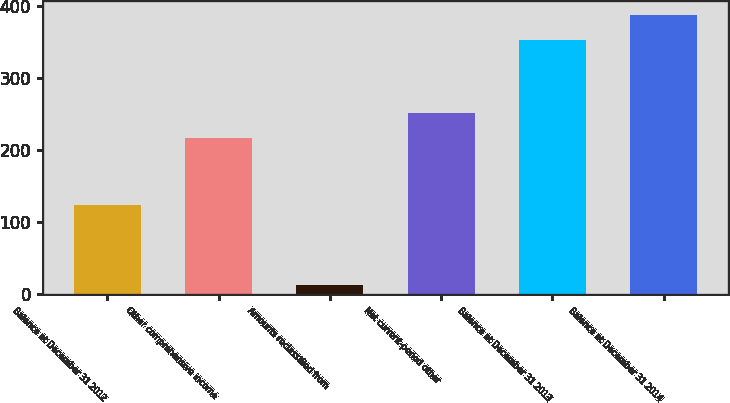<chart> <loc_0><loc_0><loc_500><loc_500><bar_chart><fcel>Balance at December 31 2012<fcel>Other comprehensive income<fcel>Amounts reclassified from<fcel>Net current-period other<fcel>Balance at December 31 2013<fcel>Balance at December 31 2014<nl><fcel>124<fcel>216<fcel>12<fcel>250.4<fcel>352<fcel>386.4<nl></chart> 